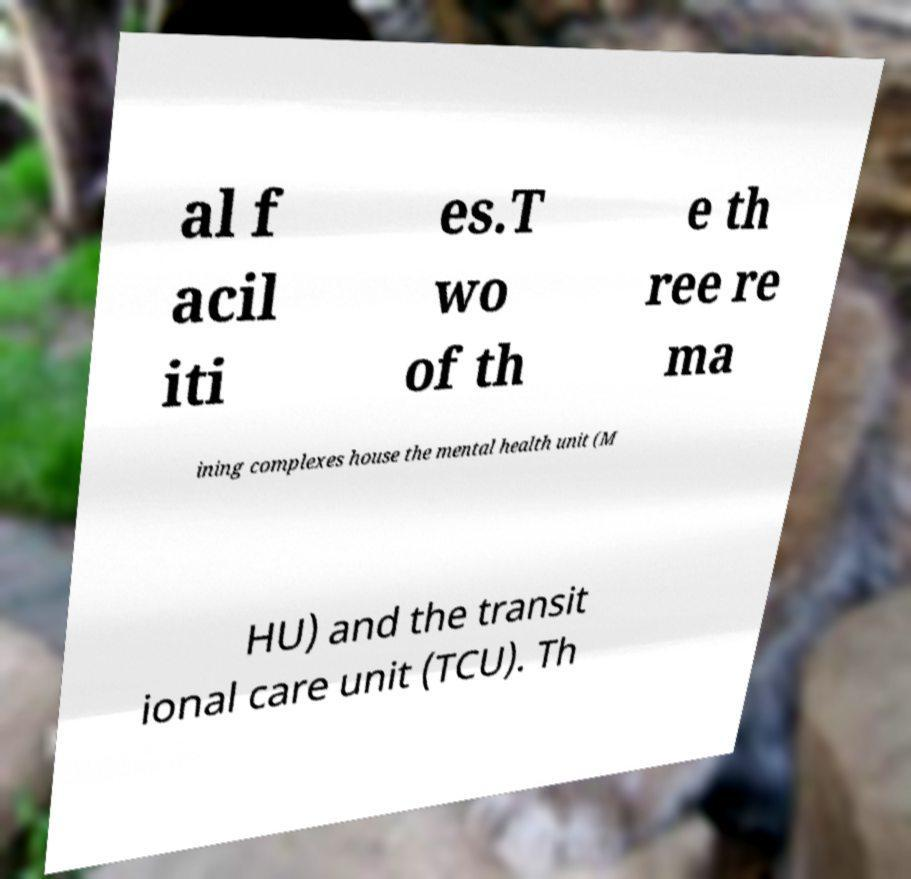Please read and relay the text visible in this image. What does it say? al f acil iti es.T wo of th e th ree re ma ining complexes house the mental health unit (M HU) and the transit ional care unit (TCU). Th 